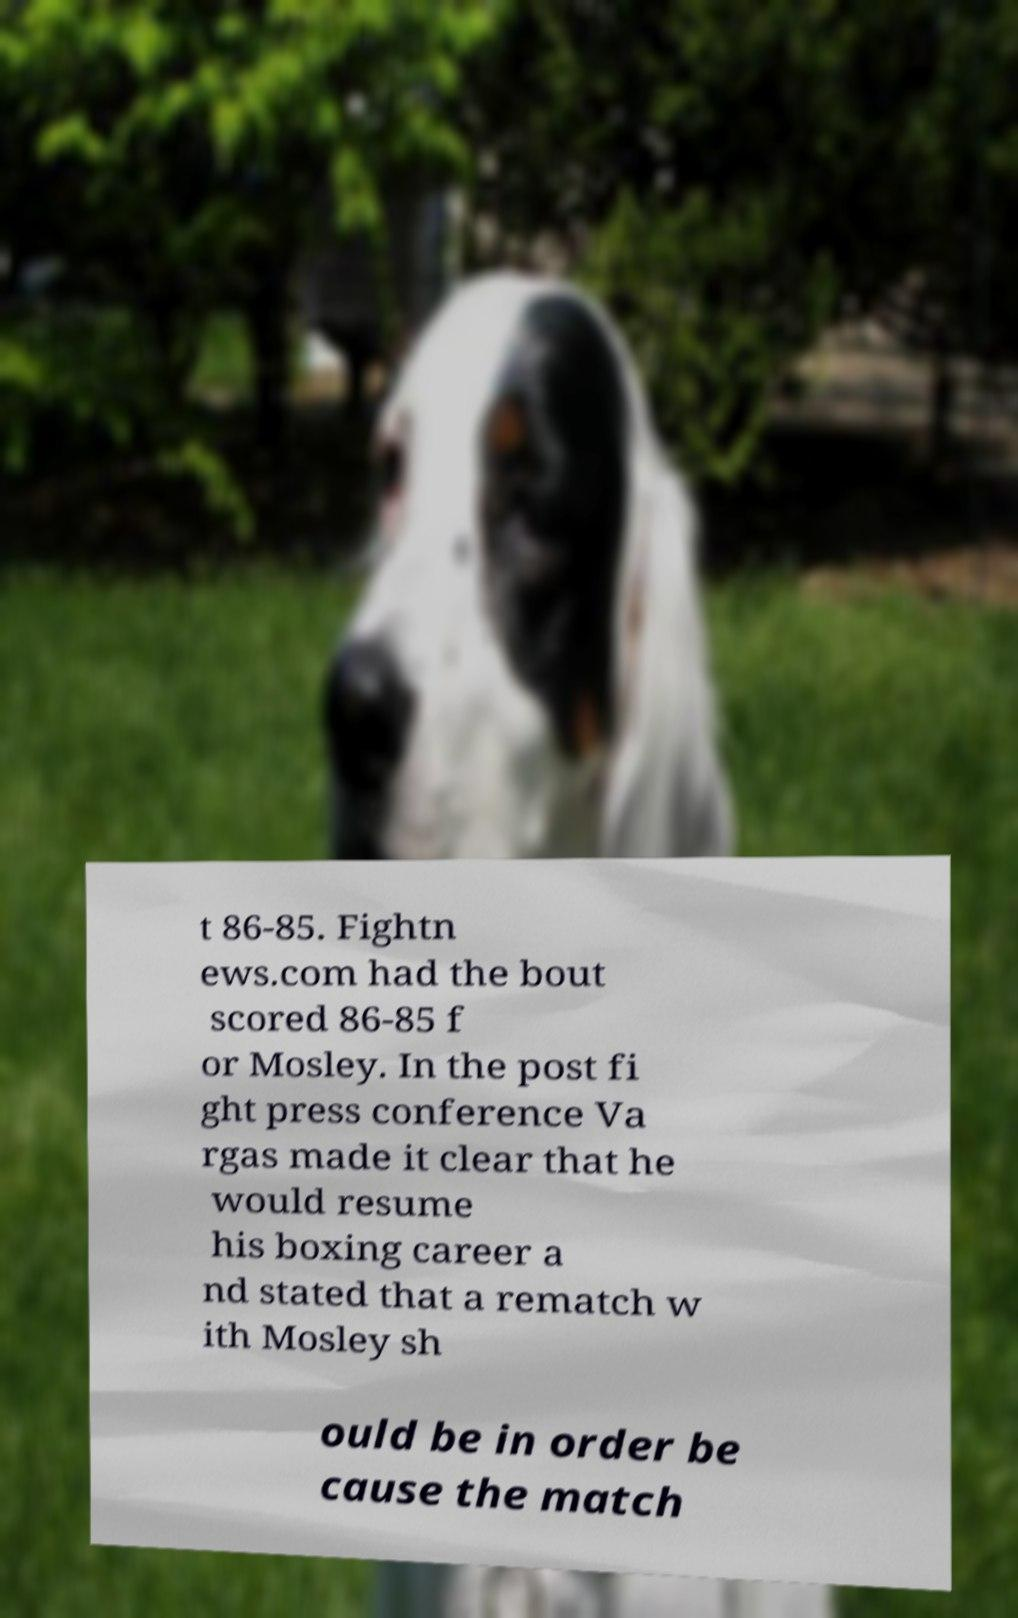Can you read and provide the text displayed in the image?This photo seems to have some interesting text. Can you extract and type it out for me? t 86-85. Fightn ews.com had the bout scored 86-85 f or Mosley. In the post fi ght press conference Va rgas made it clear that he would resume his boxing career a nd stated that a rematch w ith Mosley sh ould be in order be cause the match 